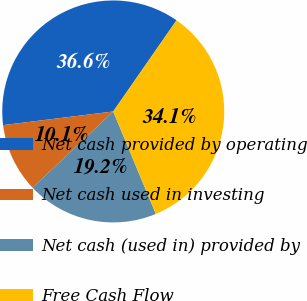Convert chart to OTSL. <chart><loc_0><loc_0><loc_500><loc_500><pie_chart><fcel>Net cash provided by operating<fcel>Net cash used in investing<fcel>Net cash (used in) provided by<fcel>Free Cash Flow<nl><fcel>36.63%<fcel>10.09%<fcel>19.21%<fcel>34.07%<nl></chart> 